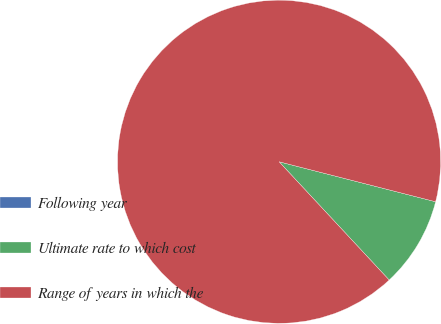Convert chart to OTSL. <chart><loc_0><loc_0><loc_500><loc_500><pie_chart><fcel>Following year<fcel>Ultimate rate to which cost<fcel>Range of years in which the<nl><fcel>0.0%<fcel>9.09%<fcel>90.91%<nl></chart> 